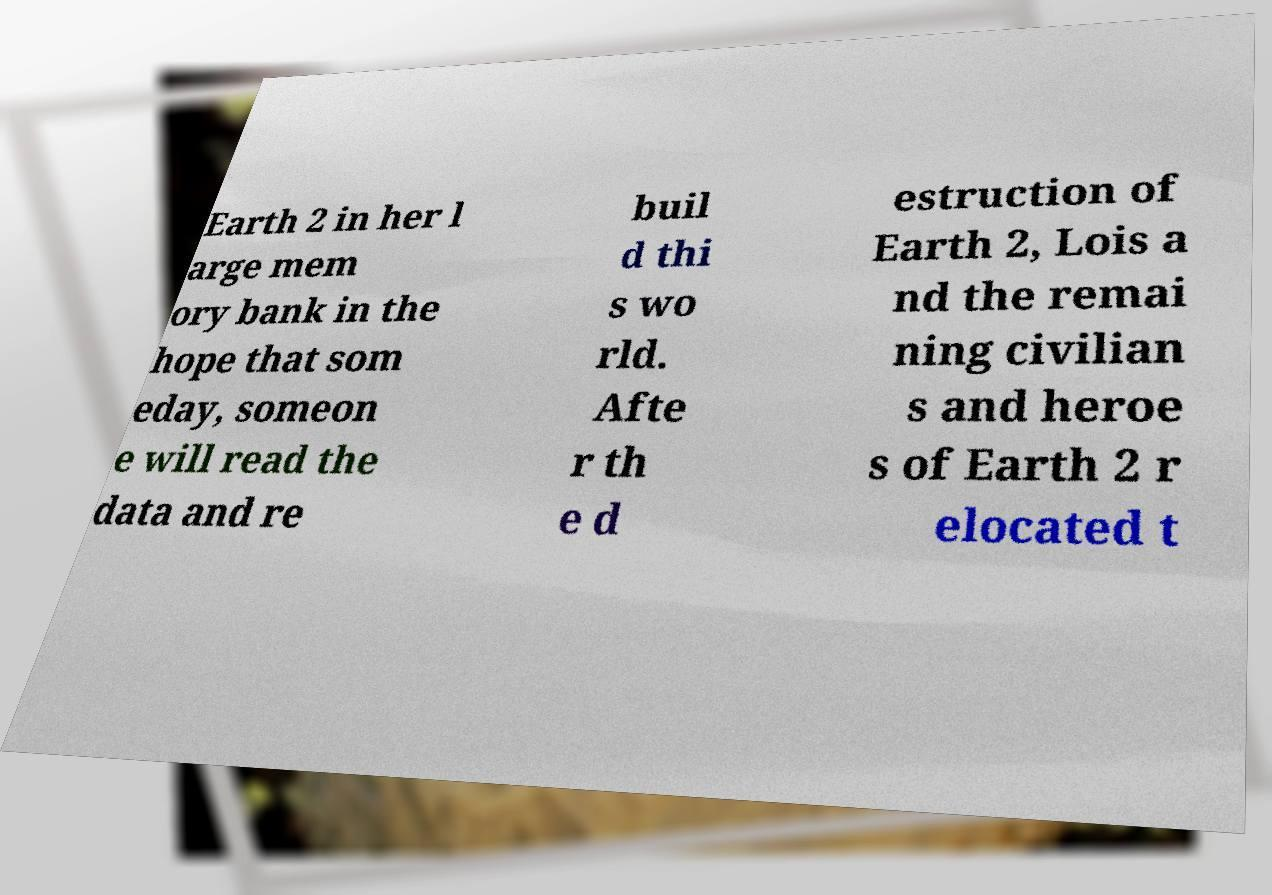Could you extract and type out the text from this image? Earth 2 in her l arge mem ory bank in the hope that som eday, someon e will read the data and re buil d thi s wo rld. Afte r th e d estruction of Earth 2, Lois a nd the remai ning civilian s and heroe s of Earth 2 r elocated t 